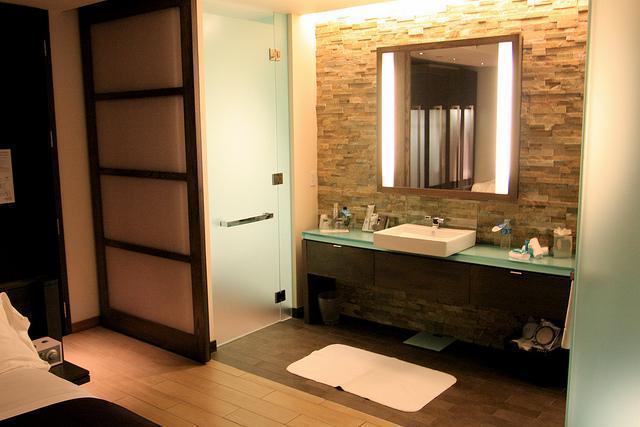How many people are wearing yellow shirt?
Give a very brief answer. 0. 